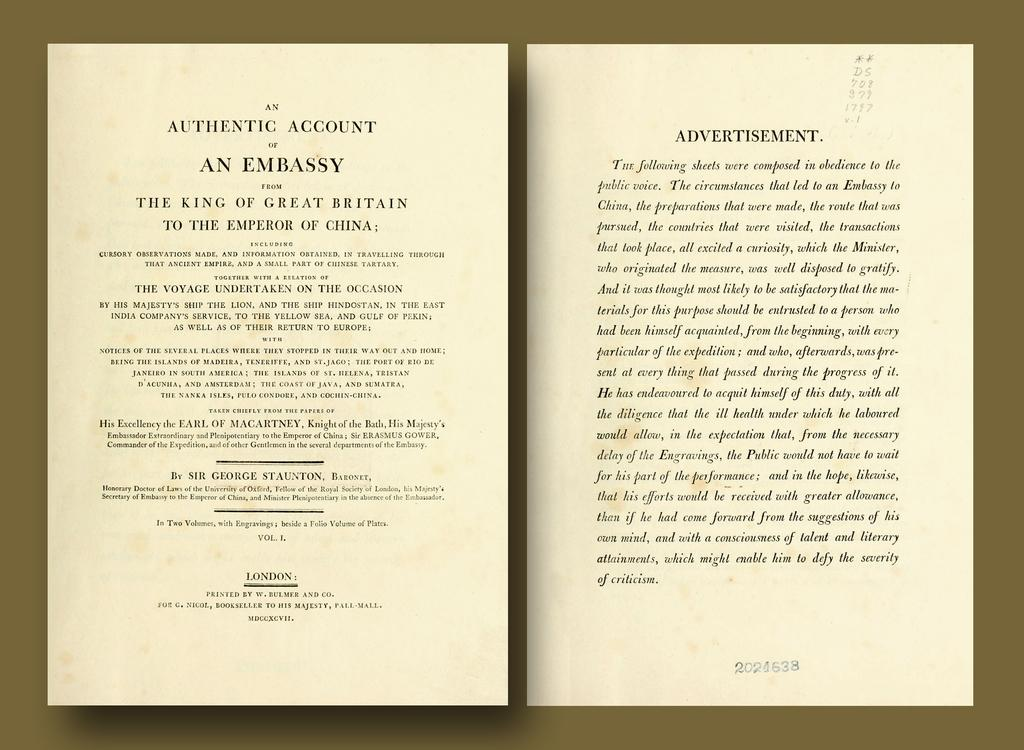Provide a one-sentence caption for the provided image. an open book to the page that says an authentic account. 